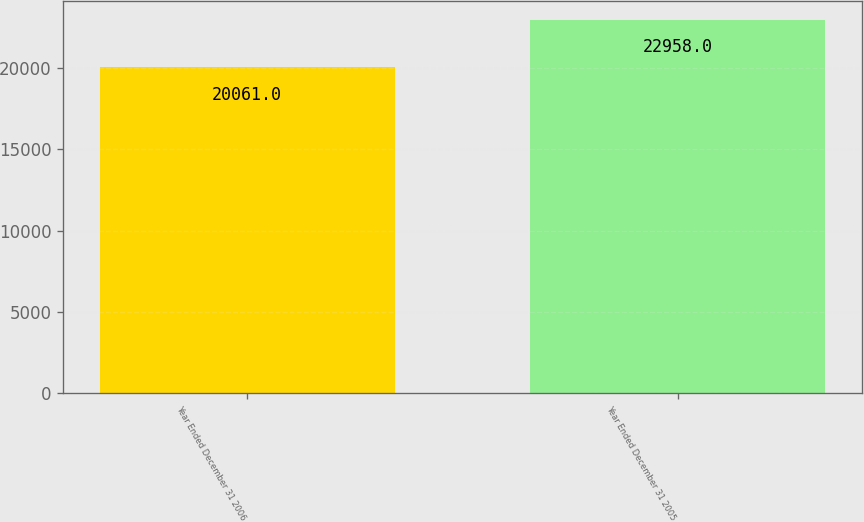Convert chart. <chart><loc_0><loc_0><loc_500><loc_500><bar_chart><fcel>Year Ended December 31 2006<fcel>Year Ended December 31 2005<nl><fcel>20061<fcel>22958<nl></chart> 